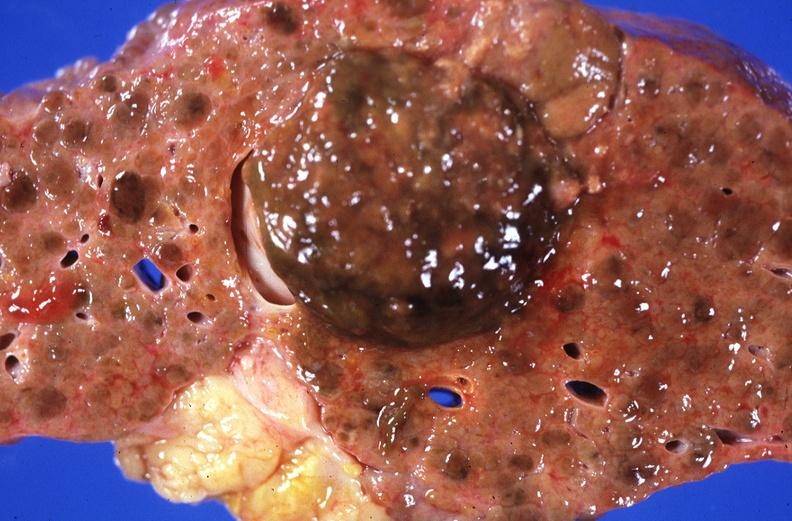s myelomonocytic leukemia present?
Answer the question using a single word or phrase. No 